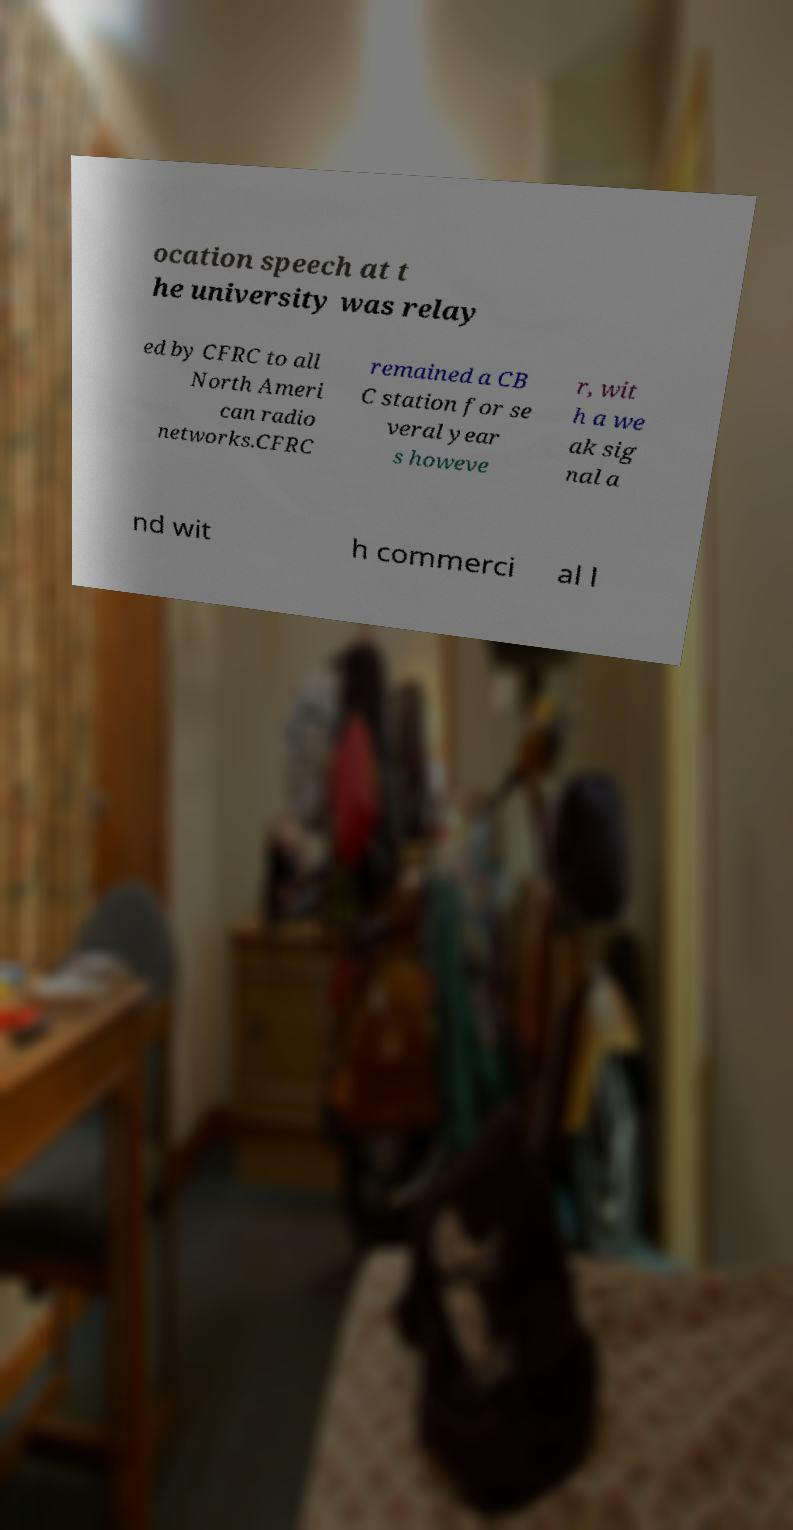There's text embedded in this image that I need extracted. Can you transcribe it verbatim? ocation speech at t he university was relay ed by CFRC to all North Ameri can radio networks.CFRC remained a CB C station for se veral year s howeve r, wit h a we ak sig nal a nd wit h commerci al l 